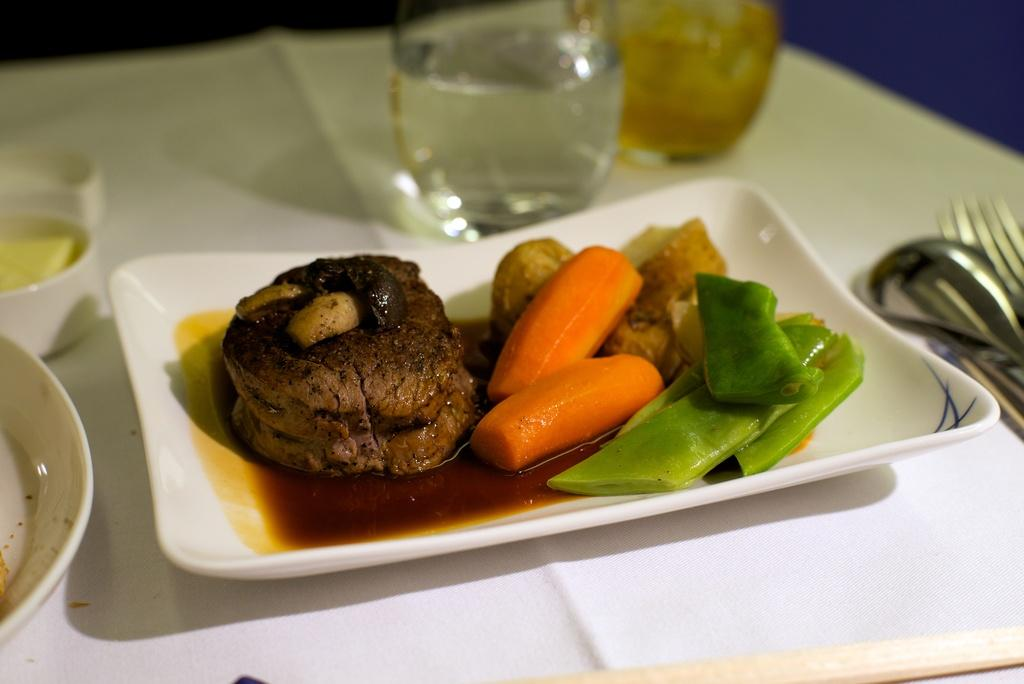What is on the plate in the image? There are food items in a plate in the image. What utensil can be seen in the image? There is a spoon in the image. What other utensil is present in the image? There are forks in the image. What else can be found on the platform in the image? There are other objects on the platform in the image. What type of sheet is being used to cover the food in the image? There is no sheet present in the image; the food items are visible on the plate. 